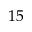<formula> <loc_0><loc_0><loc_500><loc_500>1 5</formula> 